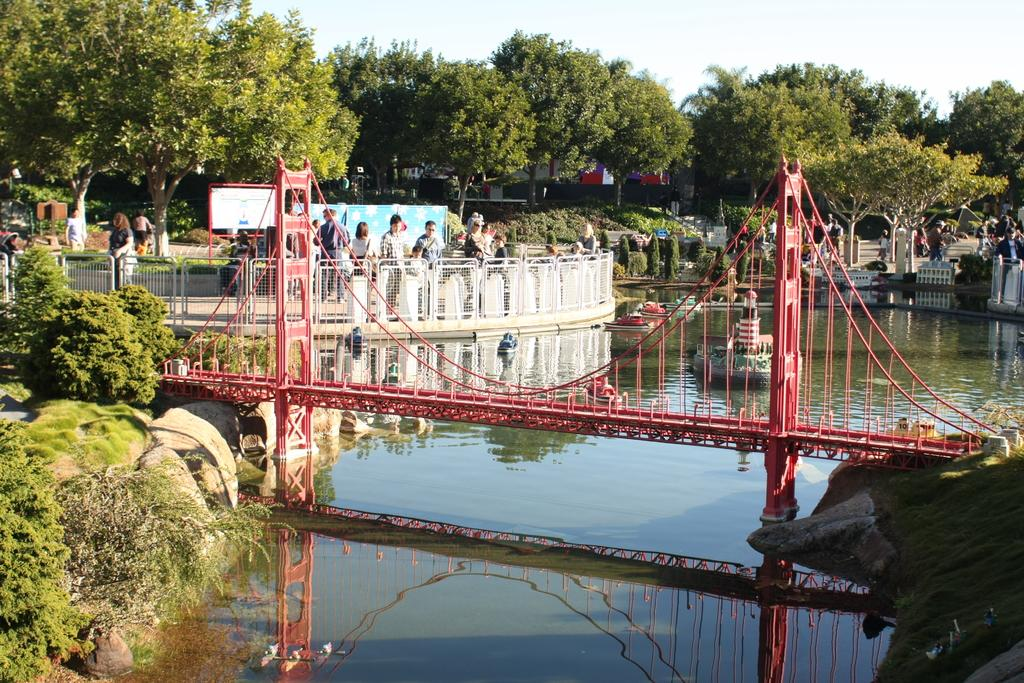What is the main structure visible above the water in the image? There is a bridge above the water in the image. What type of vehicles can be seen in the water? There are boats in the water. What is the purpose of the barrier in the image? There is a fence in the image, which may serve as a barrier or boundary. What can be seen behind the fence? People are visible behind the fence, and there is a hoarding visible as well. What type of vegetation is present in the image? Trees and plants are present in the image. How would you describe the weather based on the image? The sky is cloudy in the image. How many clocks are hanging on the trees in the image? There are no clocks hanging on the trees in the image. What type of paper is being used to create the boats in the image? The boats in the image are not made of paper; they are actual boats in the water. 